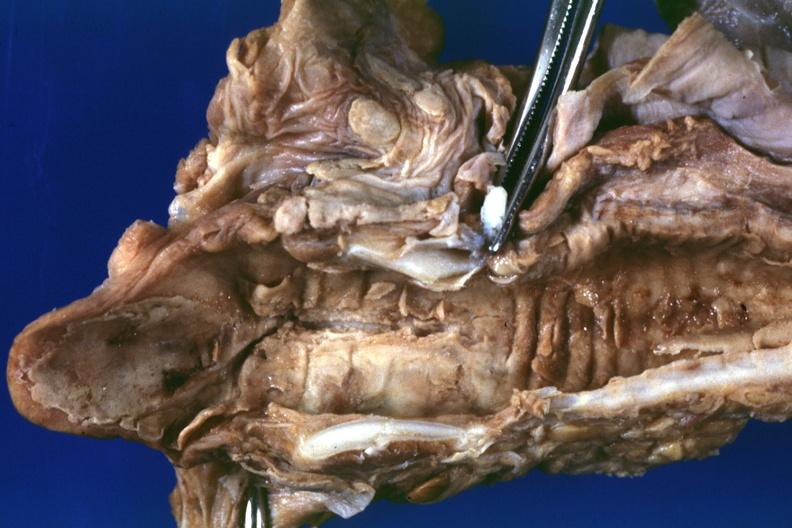s the superior vena cava present?
Answer the question using a single word or phrase. No 